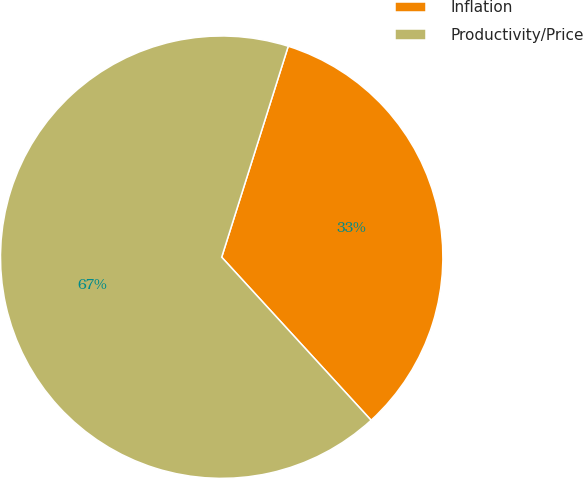Convert chart. <chart><loc_0><loc_0><loc_500><loc_500><pie_chart><fcel>Inflation<fcel>Productivity/Price<nl><fcel>33.33%<fcel>66.67%<nl></chart> 